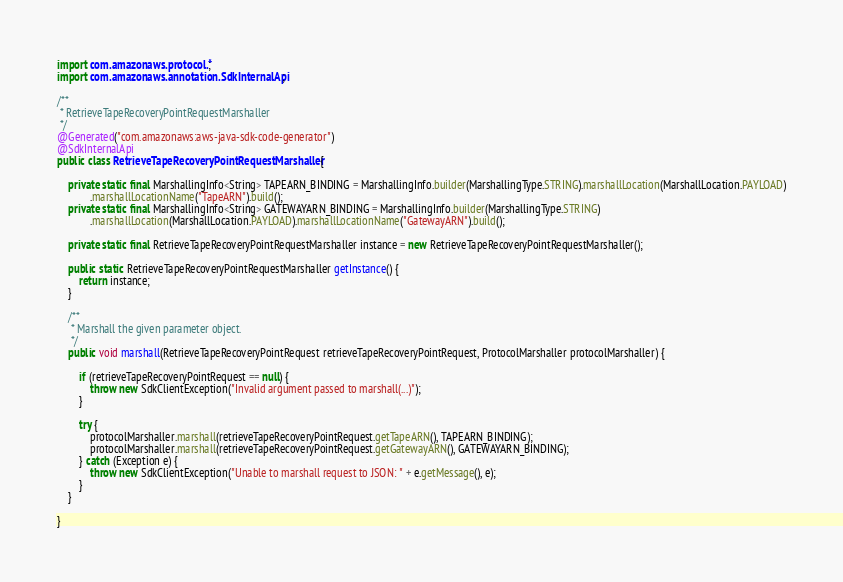<code> <loc_0><loc_0><loc_500><loc_500><_Java_>
import com.amazonaws.protocol.*;
import com.amazonaws.annotation.SdkInternalApi;

/**
 * RetrieveTapeRecoveryPointRequestMarshaller
 */
@Generated("com.amazonaws:aws-java-sdk-code-generator")
@SdkInternalApi
public class RetrieveTapeRecoveryPointRequestMarshaller {

    private static final MarshallingInfo<String> TAPEARN_BINDING = MarshallingInfo.builder(MarshallingType.STRING).marshallLocation(MarshallLocation.PAYLOAD)
            .marshallLocationName("TapeARN").build();
    private static final MarshallingInfo<String> GATEWAYARN_BINDING = MarshallingInfo.builder(MarshallingType.STRING)
            .marshallLocation(MarshallLocation.PAYLOAD).marshallLocationName("GatewayARN").build();

    private static final RetrieveTapeRecoveryPointRequestMarshaller instance = new RetrieveTapeRecoveryPointRequestMarshaller();

    public static RetrieveTapeRecoveryPointRequestMarshaller getInstance() {
        return instance;
    }

    /**
     * Marshall the given parameter object.
     */
    public void marshall(RetrieveTapeRecoveryPointRequest retrieveTapeRecoveryPointRequest, ProtocolMarshaller protocolMarshaller) {

        if (retrieveTapeRecoveryPointRequest == null) {
            throw new SdkClientException("Invalid argument passed to marshall(...)");
        }

        try {
            protocolMarshaller.marshall(retrieveTapeRecoveryPointRequest.getTapeARN(), TAPEARN_BINDING);
            protocolMarshaller.marshall(retrieveTapeRecoveryPointRequest.getGatewayARN(), GATEWAYARN_BINDING);
        } catch (Exception e) {
            throw new SdkClientException("Unable to marshall request to JSON: " + e.getMessage(), e);
        }
    }

}
</code> 